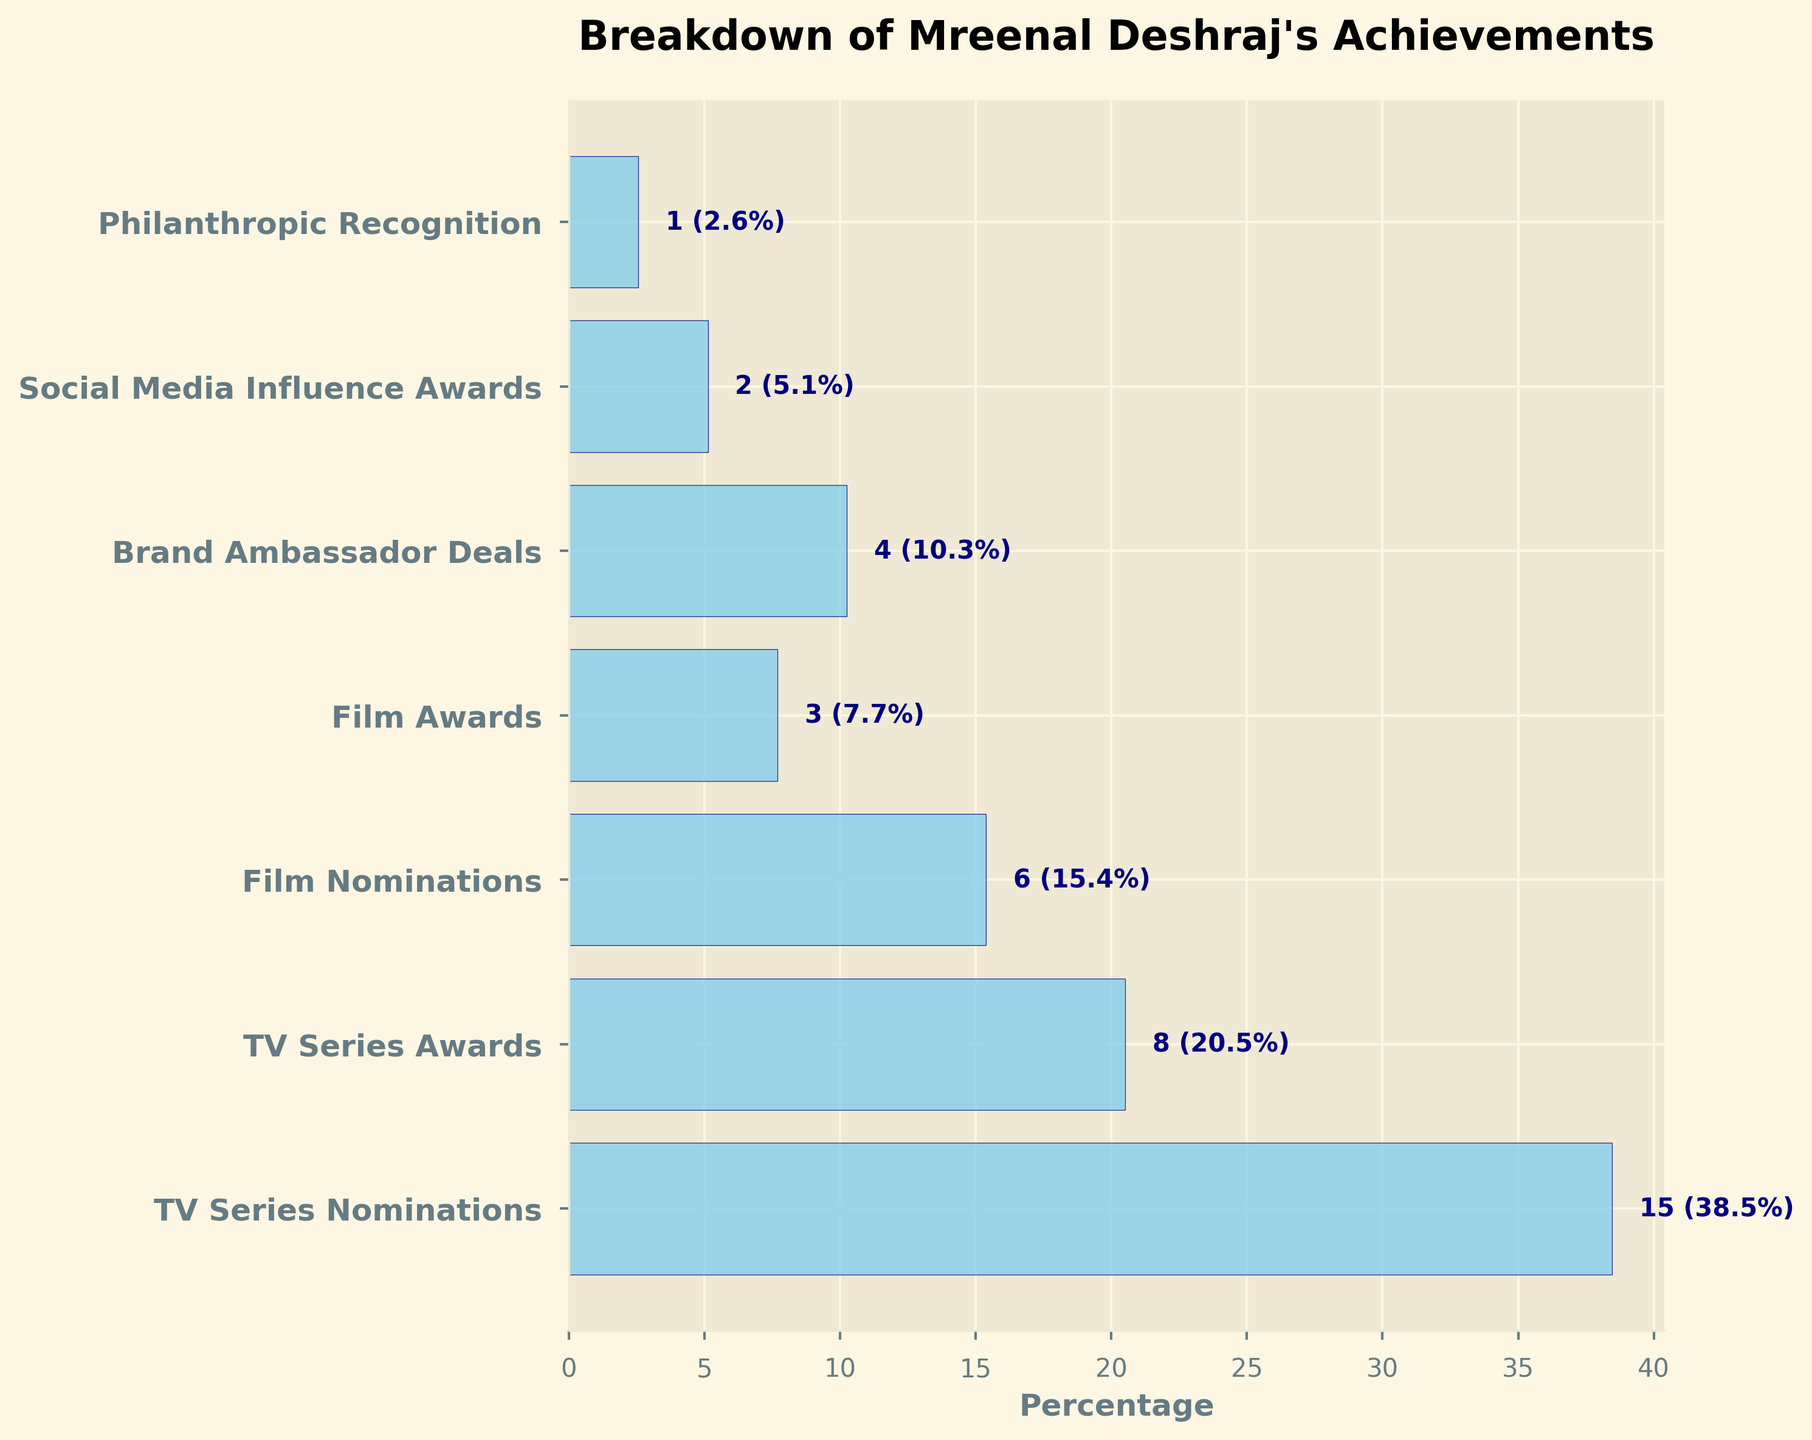What is the title of the chart? The title is usually located at the top of the chart. By looking at the top, we can see the title of the funnel chart.
Answer: Breakdown of Mreenal Deshraj's Achievements Which category has the highest count? By observing the lengths of the bars, the longest bar corresponds to the category with the highest count.
Answer: TV Series Nominations How many categories are analyzed in the funnel chart? Counting the number of horizontal bars or entries on the y-axis will provide the total number of categories.
Answer: 7 What percentage does TV Series Awards represent? By looking at the value label next to the TV Series Awards bar, which shows the percentage.
Answer: 14.8% What is the total count for the Film Awards and TV Series Awards combined? Sum the counts for Film Awards and TV Series Awards (3 + 8).
Answer: 11 Which category has the smallest count? The shortest bar corresponds to the category with the smallest count.
Answer: Philanthropic Recognition How many more nominations does Mreenal Deshraj have in TV Series compared to Films? Subtract the count of Film Nominations from TV Series Nominations (15 - 6).
Answer: 9 What is the difference in count between Brand Ambassador Deals and Social Media Influence Awards? Subtract the count of Social Media Influence Awards from Brand Ambassador Deals (4 - 2).
Answer: 2 Which categories have counts below 5? Identify the categories whose bars represent counts less than 5.
Answer: Film Awards, Brand Ambassador Deals, Social Media Influence Awards, Philanthropic Recognition What is the total percentage accounted for by TV Series Nominations and Awards? Sum the percentages of TV Series Nominations (27.8%) and TV Series Awards (14.8%). Note the data needed from the figure itself.
Answer: 42.6% 